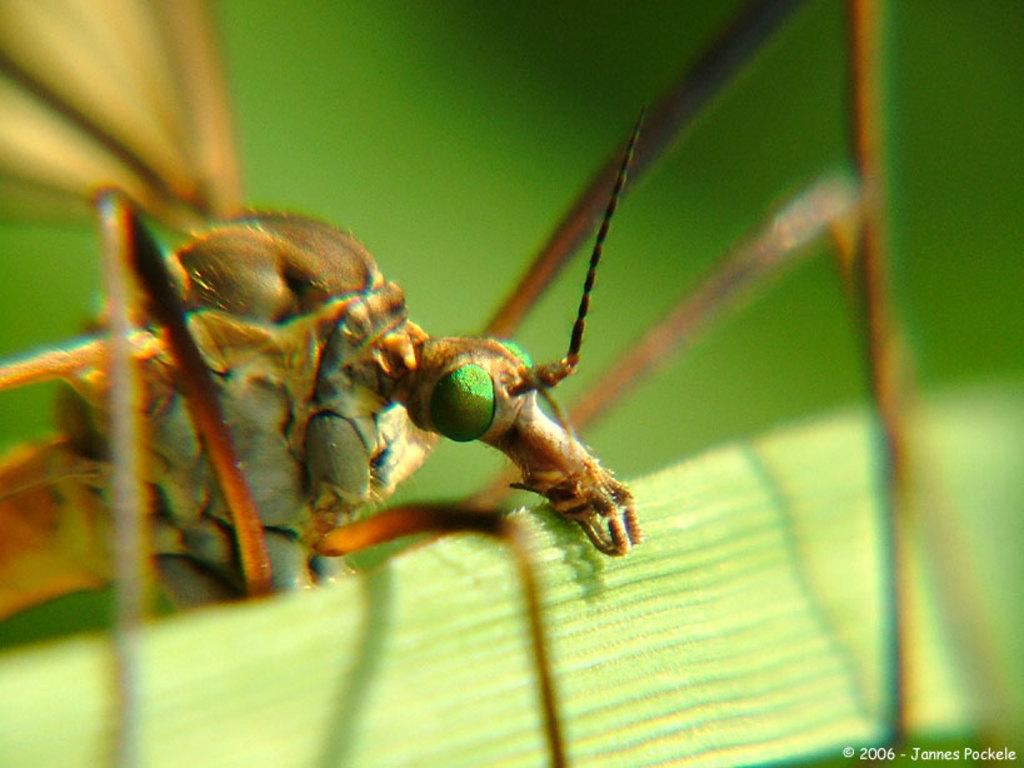What type of creature is in the image? There is an insect in the image. What is the insect sitting on? The insect is on a green object. Can you describe any additional features of the image? There is a watermark on the image. How many dinosaurs can be seen in the image? There are no dinosaurs present in the image; it features an insect on a green object. What is the limit of the insect's reasoning abilities in the image? Insects do not have reasoning abilities, so this question cannot be answered based on the image. 